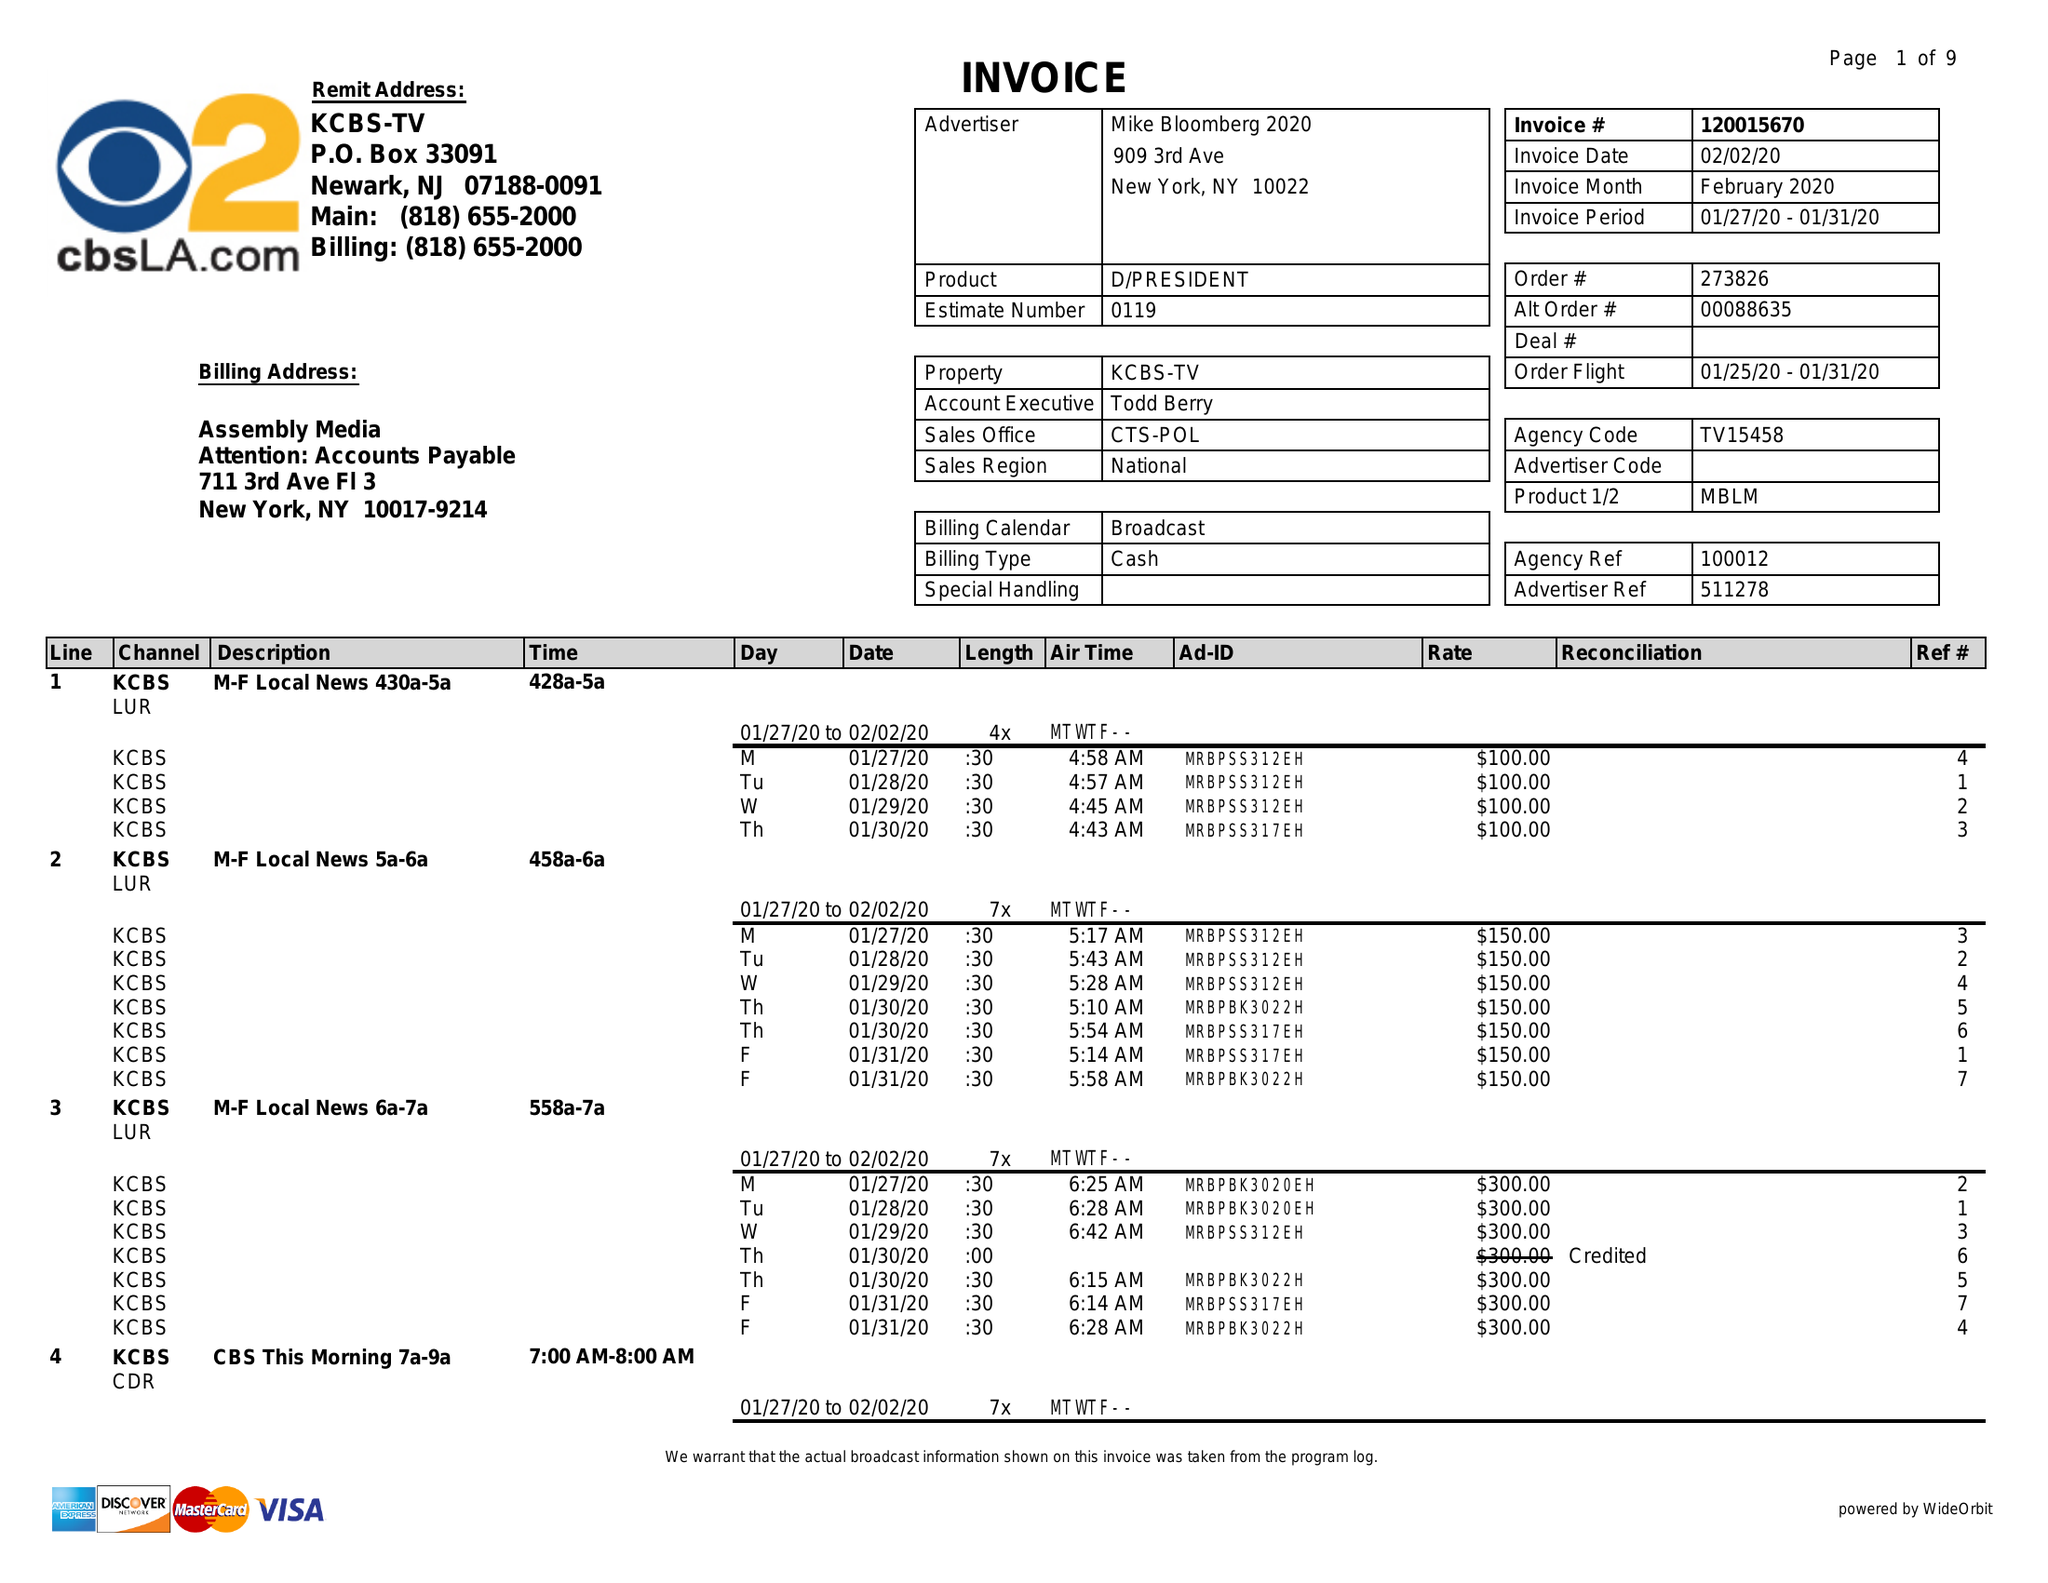What is the value for the advertiser?
Answer the question using a single word or phrase. MIKE BLOOMBERG 2020 